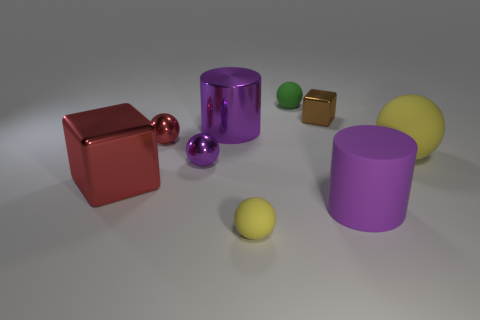There is a rubber sphere behind the red metal sphere; what size is it?
Offer a terse response. Small. There is a big purple thing behind the large object to the left of the small red ball; what is its shape?
Offer a very short reply. Cylinder. There is another large object that is the same shape as the brown object; what color is it?
Your response must be concise. Red. Does the matte cylinder to the right of the brown block have the same size as the large yellow sphere?
Offer a very short reply. Yes. There is a big thing that is the same color as the matte cylinder; what shape is it?
Provide a short and direct response. Cylinder. What number of red balls have the same material as the tiny green thing?
Offer a terse response. 0. What material is the big purple thing behind the big cylinder that is right of the small metal object right of the tiny purple object?
Give a very brief answer. Metal. There is a small thing that is in front of the cylinder that is in front of the purple sphere; what color is it?
Your response must be concise. Yellow. What is the color of the rubber thing that is the same size as the matte cylinder?
Keep it short and to the point. Yellow. How many big objects are red shiny balls or purple rubber cylinders?
Provide a succinct answer. 1. 